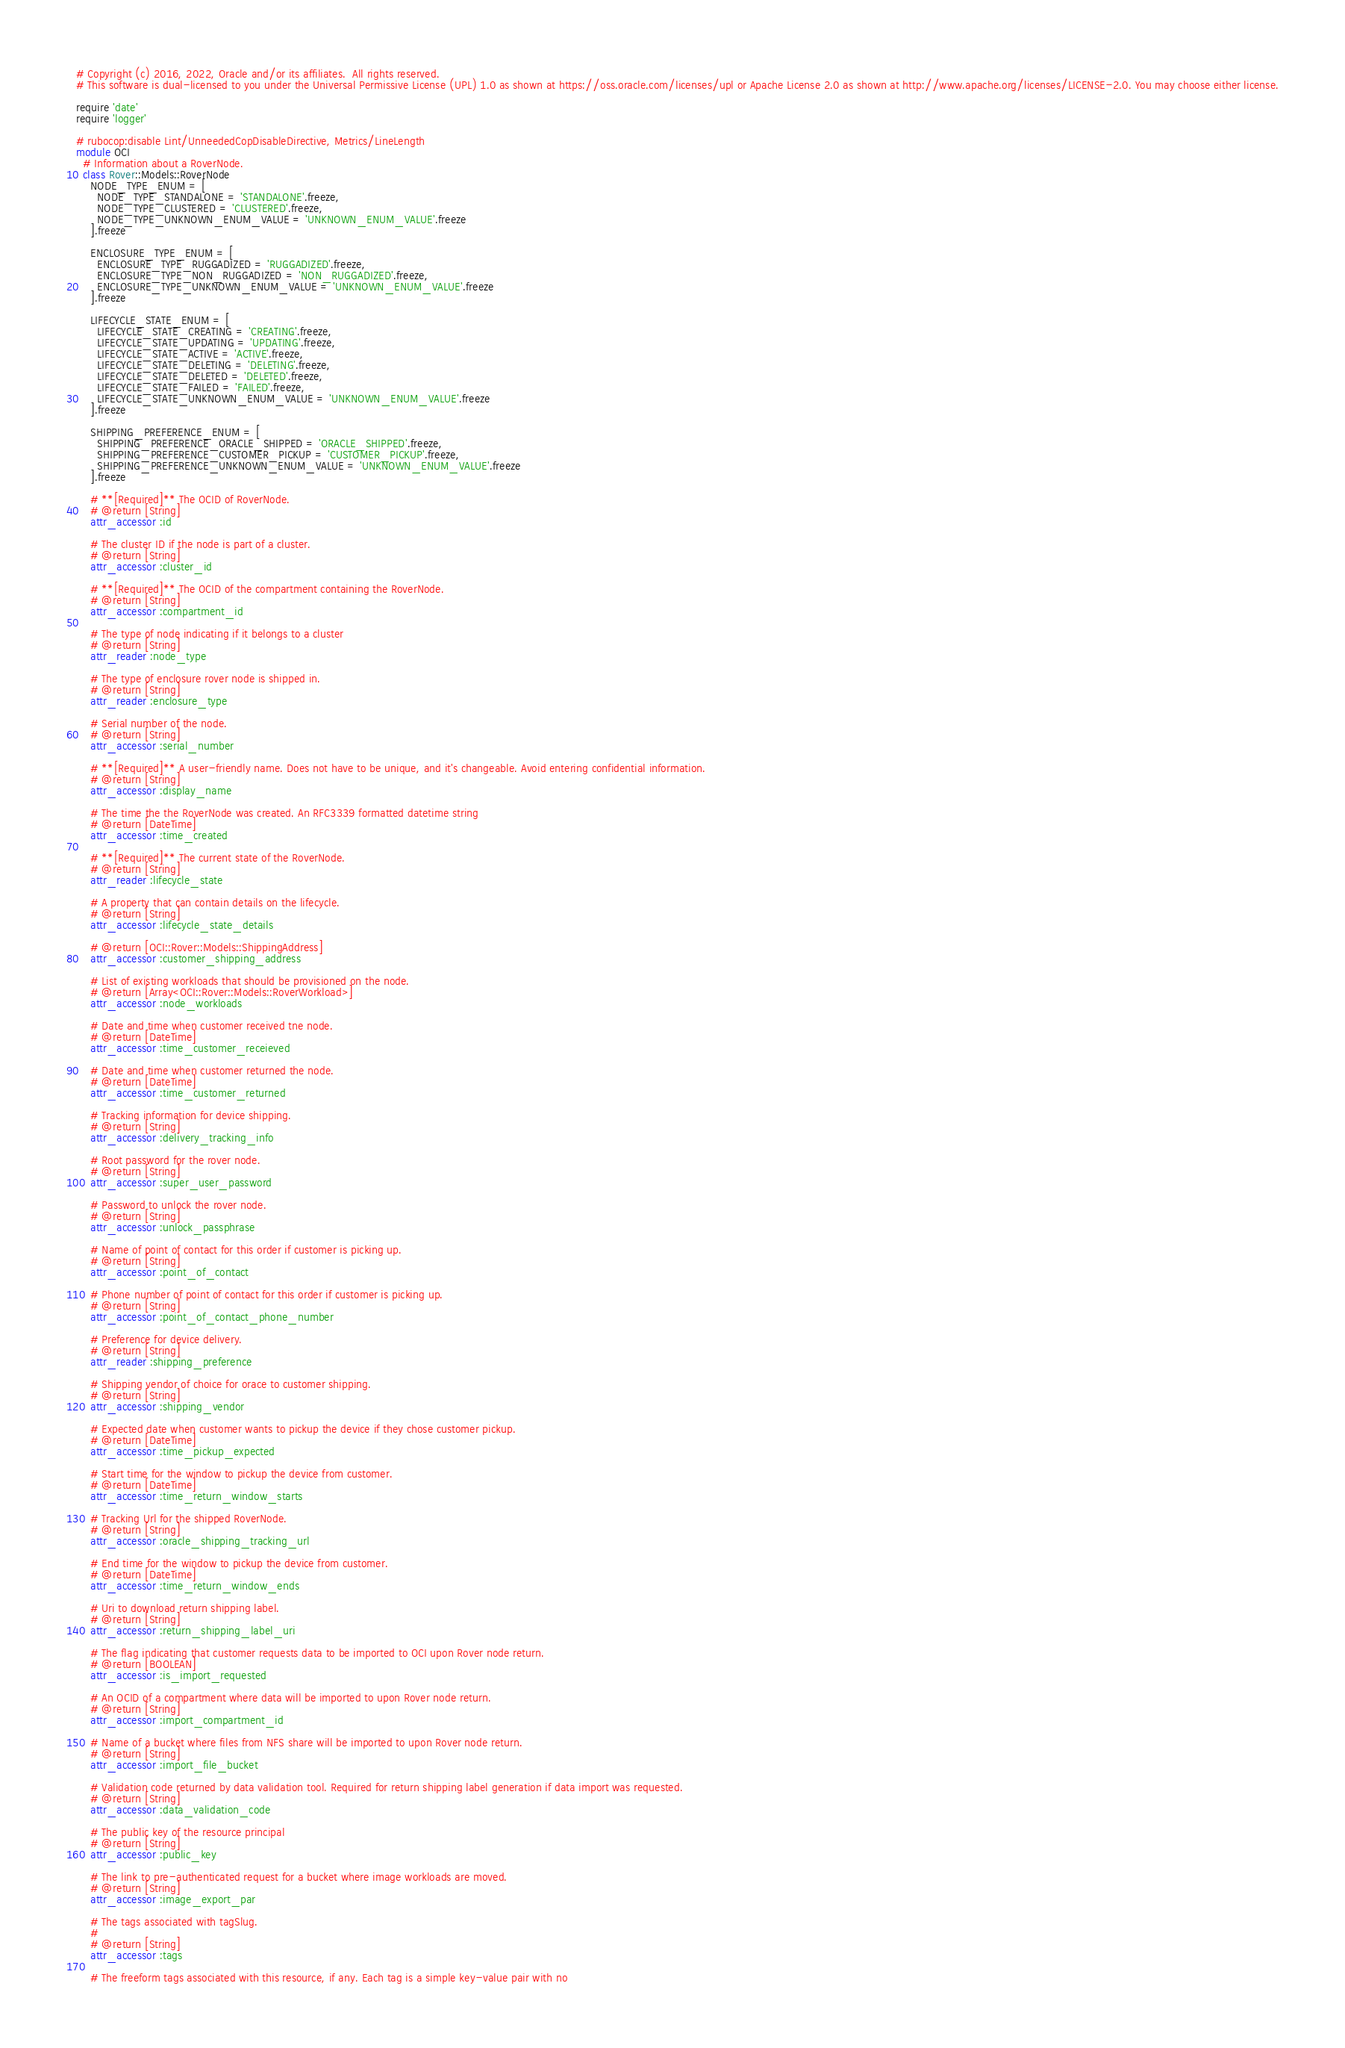<code> <loc_0><loc_0><loc_500><loc_500><_Ruby_># Copyright (c) 2016, 2022, Oracle and/or its affiliates.  All rights reserved.
# This software is dual-licensed to you under the Universal Permissive License (UPL) 1.0 as shown at https://oss.oracle.com/licenses/upl or Apache License 2.0 as shown at http://www.apache.org/licenses/LICENSE-2.0. You may choose either license.

require 'date'
require 'logger'

# rubocop:disable Lint/UnneededCopDisableDirective, Metrics/LineLength
module OCI
  # Information about a RoverNode.
  class Rover::Models::RoverNode
    NODE_TYPE_ENUM = [
      NODE_TYPE_STANDALONE = 'STANDALONE'.freeze,
      NODE_TYPE_CLUSTERED = 'CLUSTERED'.freeze,
      NODE_TYPE_UNKNOWN_ENUM_VALUE = 'UNKNOWN_ENUM_VALUE'.freeze
    ].freeze

    ENCLOSURE_TYPE_ENUM = [
      ENCLOSURE_TYPE_RUGGADIZED = 'RUGGADIZED'.freeze,
      ENCLOSURE_TYPE_NON_RUGGADIZED = 'NON_RUGGADIZED'.freeze,
      ENCLOSURE_TYPE_UNKNOWN_ENUM_VALUE = 'UNKNOWN_ENUM_VALUE'.freeze
    ].freeze

    LIFECYCLE_STATE_ENUM = [
      LIFECYCLE_STATE_CREATING = 'CREATING'.freeze,
      LIFECYCLE_STATE_UPDATING = 'UPDATING'.freeze,
      LIFECYCLE_STATE_ACTIVE = 'ACTIVE'.freeze,
      LIFECYCLE_STATE_DELETING = 'DELETING'.freeze,
      LIFECYCLE_STATE_DELETED = 'DELETED'.freeze,
      LIFECYCLE_STATE_FAILED = 'FAILED'.freeze,
      LIFECYCLE_STATE_UNKNOWN_ENUM_VALUE = 'UNKNOWN_ENUM_VALUE'.freeze
    ].freeze

    SHIPPING_PREFERENCE_ENUM = [
      SHIPPING_PREFERENCE_ORACLE_SHIPPED = 'ORACLE_SHIPPED'.freeze,
      SHIPPING_PREFERENCE_CUSTOMER_PICKUP = 'CUSTOMER_PICKUP'.freeze,
      SHIPPING_PREFERENCE_UNKNOWN_ENUM_VALUE = 'UNKNOWN_ENUM_VALUE'.freeze
    ].freeze

    # **[Required]** The OCID of RoverNode.
    # @return [String]
    attr_accessor :id

    # The cluster ID if the node is part of a cluster.
    # @return [String]
    attr_accessor :cluster_id

    # **[Required]** The OCID of the compartment containing the RoverNode.
    # @return [String]
    attr_accessor :compartment_id

    # The type of node indicating if it belongs to a cluster
    # @return [String]
    attr_reader :node_type

    # The type of enclosure rover node is shipped in.
    # @return [String]
    attr_reader :enclosure_type

    # Serial number of the node.
    # @return [String]
    attr_accessor :serial_number

    # **[Required]** A user-friendly name. Does not have to be unique, and it's changeable. Avoid entering confidential information.
    # @return [String]
    attr_accessor :display_name

    # The time the the RoverNode was created. An RFC3339 formatted datetime string
    # @return [DateTime]
    attr_accessor :time_created

    # **[Required]** The current state of the RoverNode.
    # @return [String]
    attr_reader :lifecycle_state

    # A property that can contain details on the lifecycle.
    # @return [String]
    attr_accessor :lifecycle_state_details

    # @return [OCI::Rover::Models::ShippingAddress]
    attr_accessor :customer_shipping_address

    # List of existing workloads that should be provisioned on the node.
    # @return [Array<OCI::Rover::Models::RoverWorkload>]
    attr_accessor :node_workloads

    # Date and time when customer received tne node.
    # @return [DateTime]
    attr_accessor :time_customer_receieved

    # Date and time when customer returned the node.
    # @return [DateTime]
    attr_accessor :time_customer_returned

    # Tracking information for device shipping.
    # @return [String]
    attr_accessor :delivery_tracking_info

    # Root password for the rover node.
    # @return [String]
    attr_accessor :super_user_password

    # Password to unlock the rover node.
    # @return [String]
    attr_accessor :unlock_passphrase

    # Name of point of contact for this order if customer is picking up.
    # @return [String]
    attr_accessor :point_of_contact

    # Phone number of point of contact for this order if customer is picking up.
    # @return [String]
    attr_accessor :point_of_contact_phone_number

    # Preference for device delivery.
    # @return [String]
    attr_reader :shipping_preference

    # Shipping vendor of choice for orace to customer shipping.
    # @return [String]
    attr_accessor :shipping_vendor

    # Expected date when customer wants to pickup the device if they chose customer pickup.
    # @return [DateTime]
    attr_accessor :time_pickup_expected

    # Start time for the window to pickup the device from customer.
    # @return [DateTime]
    attr_accessor :time_return_window_starts

    # Tracking Url for the shipped RoverNode.
    # @return [String]
    attr_accessor :oracle_shipping_tracking_url

    # End time for the window to pickup the device from customer.
    # @return [DateTime]
    attr_accessor :time_return_window_ends

    # Uri to download return shipping label.
    # @return [String]
    attr_accessor :return_shipping_label_uri

    # The flag indicating that customer requests data to be imported to OCI upon Rover node return.
    # @return [BOOLEAN]
    attr_accessor :is_import_requested

    # An OCID of a compartment where data will be imported to upon Rover node return.
    # @return [String]
    attr_accessor :import_compartment_id

    # Name of a bucket where files from NFS share will be imported to upon Rover node return.
    # @return [String]
    attr_accessor :import_file_bucket

    # Validation code returned by data validation tool. Required for return shipping label generation if data import was requested.
    # @return [String]
    attr_accessor :data_validation_code

    # The public key of the resource principal
    # @return [String]
    attr_accessor :public_key

    # The link to pre-authenticated request for a bucket where image workloads are moved.
    # @return [String]
    attr_accessor :image_export_par

    # The tags associated with tagSlug.
    #
    # @return [String]
    attr_accessor :tags

    # The freeform tags associated with this resource, if any. Each tag is a simple key-value pair with no</code> 